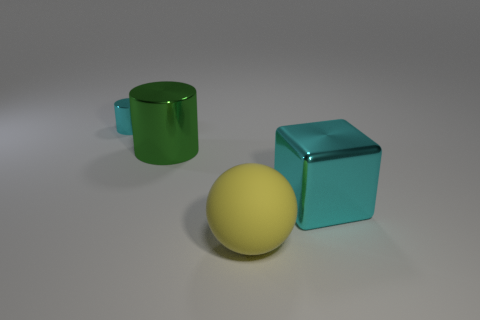Are there any other things that have the same size as the cyan metal cylinder?
Your response must be concise. No. Is the material of the cyan thing that is in front of the tiny cyan metal cylinder the same as the cylinder that is on the right side of the tiny cyan shiny object?
Provide a succinct answer. Yes. There is a cyan thing that is behind the cyan shiny thing that is on the right side of the large ball; what is its material?
Keep it short and to the point. Metal. The cyan metal object that is on the left side of the large thing that is in front of the cyan metal thing that is in front of the large green cylinder is what shape?
Your answer should be very brief. Cylinder. What is the material of the other tiny thing that is the same shape as the green object?
Your response must be concise. Metal. What number of cyan blocks are there?
Ensure brevity in your answer.  1. What shape is the cyan thing to the right of the small cyan cylinder?
Offer a terse response. Cube. What color is the large metallic thing that is left of the large metallic object on the right side of the large object left of the large yellow matte object?
Offer a very short reply. Green. What shape is the green object that is made of the same material as the cyan cube?
Provide a short and direct response. Cylinder. Is the number of gray cylinders less than the number of yellow rubber balls?
Keep it short and to the point. Yes. 